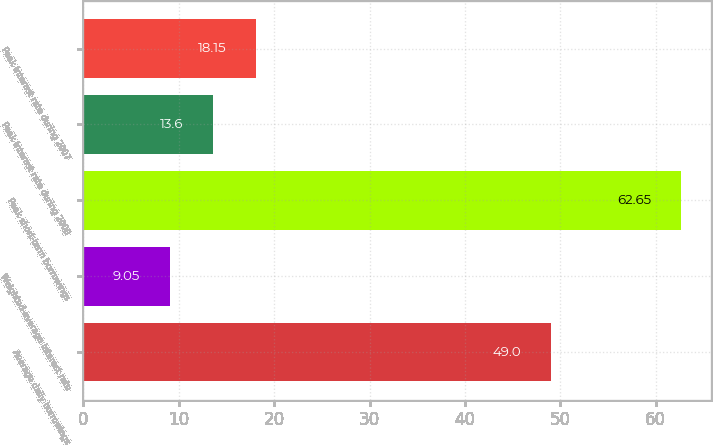<chart> <loc_0><loc_0><loc_500><loc_500><bar_chart><fcel>Average daily borrowings<fcel>Weighted-average interest rate<fcel>Peak short-term borrowings<fcel>Peak interest rate during 2008<fcel>Peak interest rate during 2007<nl><fcel>49<fcel>9.05<fcel>62.65<fcel>13.6<fcel>18.15<nl></chart> 